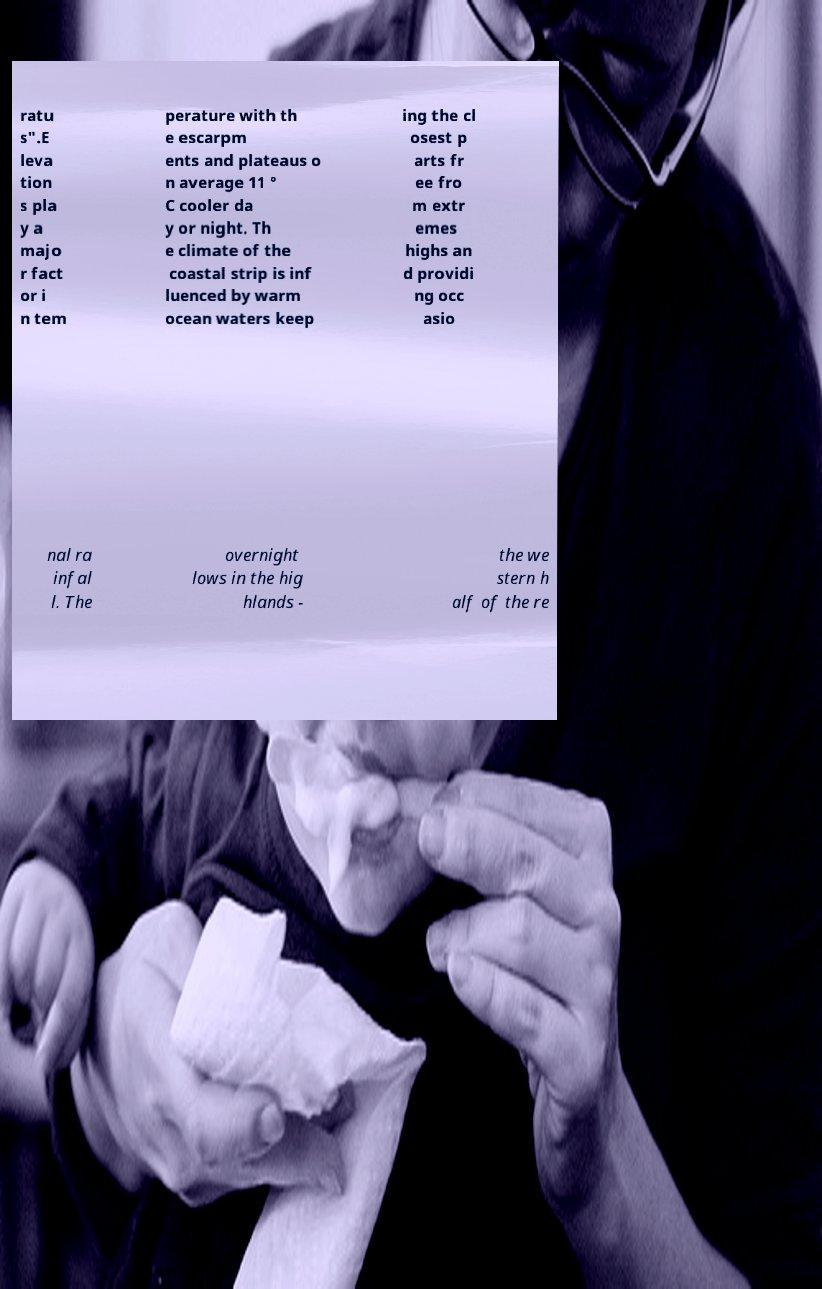Can you read and provide the text displayed in the image?This photo seems to have some interesting text. Can you extract and type it out for me? ratu s".E leva tion s pla y a majo r fact or i n tem perature with th e escarpm ents and plateaus o n average 11 ° C cooler da y or night. Th e climate of the coastal strip is inf luenced by warm ocean waters keep ing the cl osest p arts fr ee fro m extr emes highs an d providi ng occ asio nal ra infal l. The overnight lows in the hig hlands - the we stern h alf of the re 